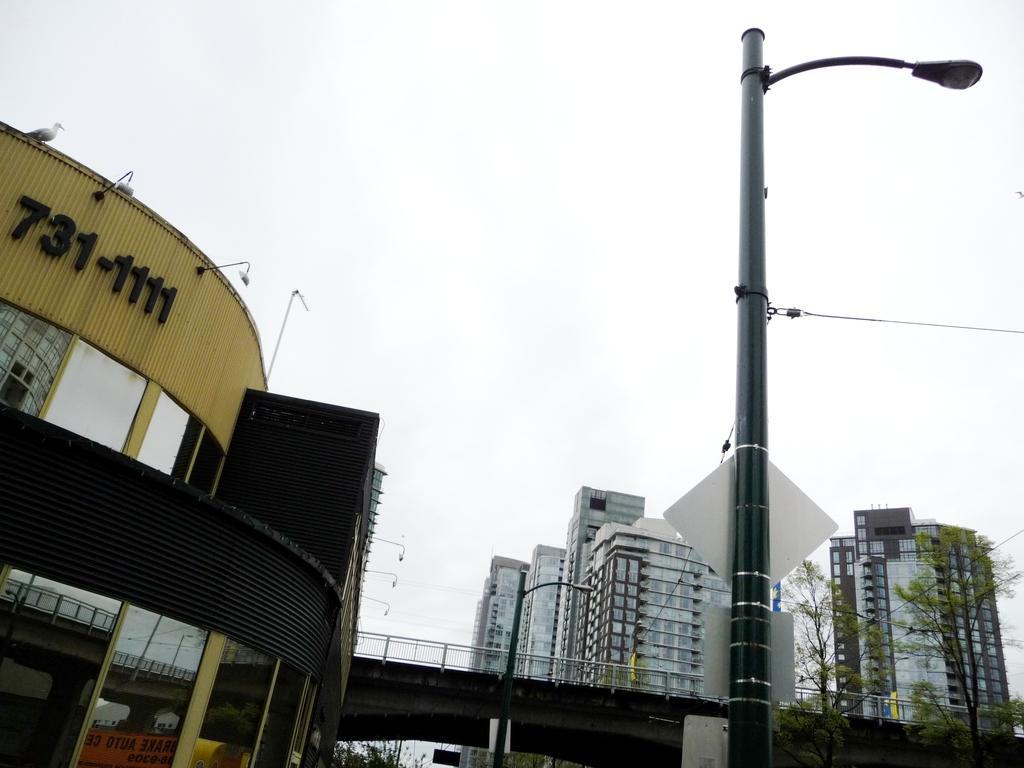In one or two sentences, can you explain what this image depicts? In this image in front there are street lights. At the center of the image there is a bridge. In the background there are buildings, trees and sky. 